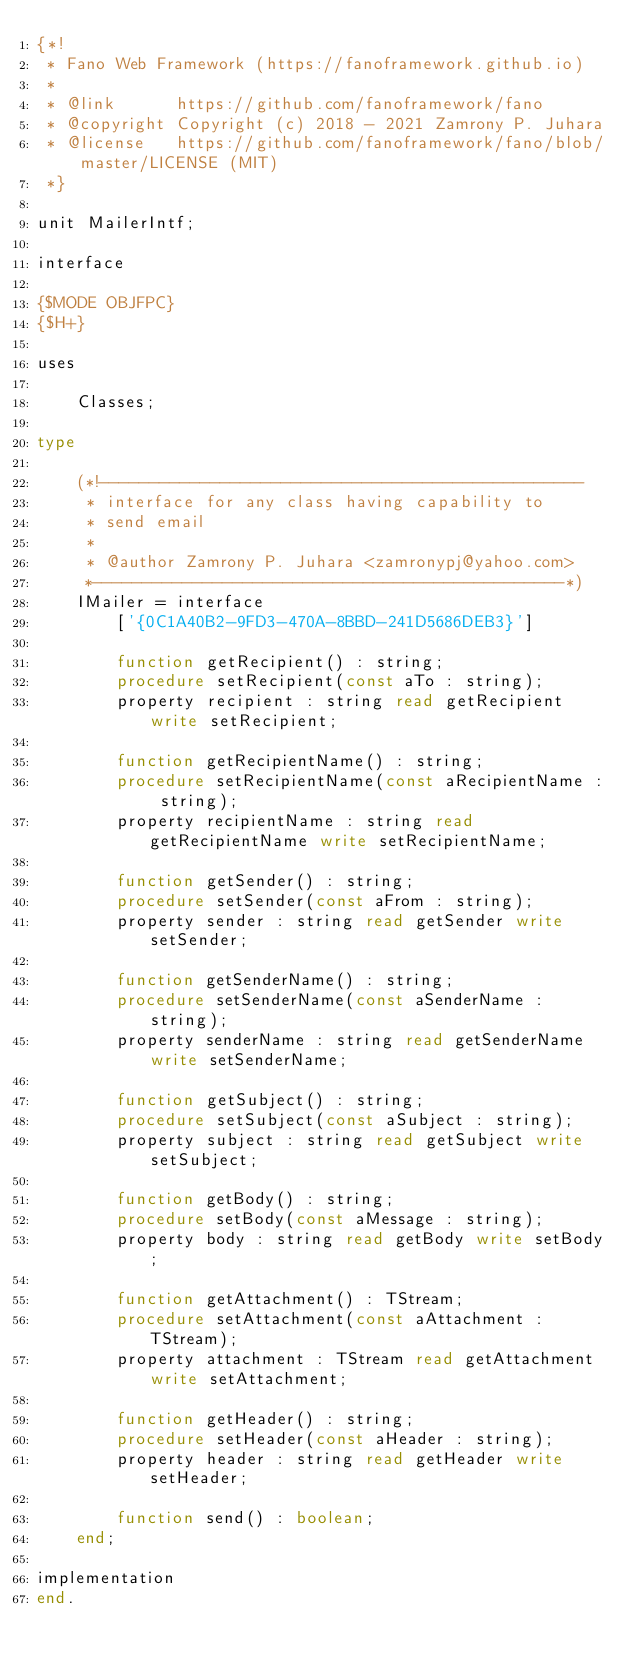<code> <loc_0><loc_0><loc_500><loc_500><_Pascal_>{*!
 * Fano Web Framework (https://fanoframework.github.io)
 *
 * @link      https://github.com/fanoframework/fano
 * @copyright Copyright (c) 2018 - 2021 Zamrony P. Juhara
 * @license   https://github.com/fanoframework/fano/blob/master/LICENSE (MIT)
 *}

unit MailerIntf;

interface

{$MODE OBJFPC}
{$H+}

uses

    Classes;

type

    (*!------------------------------------------------
     * interface for any class having capability to
     * send email
     *
     * @author Zamrony P. Juhara <zamronypj@yahoo.com>
     *-----------------------------------------------*)
    IMailer = interface
        ['{0C1A40B2-9FD3-470A-8BBD-241D5686DEB3}']

        function getRecipient() : string;
        procedure setRecipient(const aTo : string);
        property recipient : string read getRecipient write setRecipient;

        function getRecipientName() : string;
        procedure setRecipientName(const aRecipientName : string);
        property recipientName : string read getRecipientName write setRecipientName;

        function getSender() : string;
        procedure setSender(const aFrom : string);
        property sender : string read getSender write setSender;

        function getSenderName() : string;
        procedure setSenderName(const aSenderName : string);
        property senderName : string read getSenderName write setSenderName;

        function getSubject() : string;
        procedure setSubject(const aSubject : string);
        property subject : string read getSubject write setSubject;

        function getBody() : string;
        procedure setBody(const aMessage : string);
        property body : string read getBody write setBody;

        function getAttachment() : TStream;
        procedure setAttachment(const aAttachment : TStream);
        property attachment : TStream read getAttachment write setAttachment;

        function getHeader() : string;
        procedure setHeader(const aHeader : string);
        property header : string read getHeader write setHeader;

        function send() : boolean;
    end;

implementation
end.
</code> 